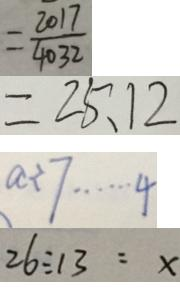Convert formula to latex. <formula><loc_0><loc_0><loc_500><loc_500>= \frac { 2 0 1 7 } { 4 0 3 2 } 
 = 2 5 . 1 2 
 a \div 7 \cdots 4 
 2 6 \div 1 3 = x</formula> 